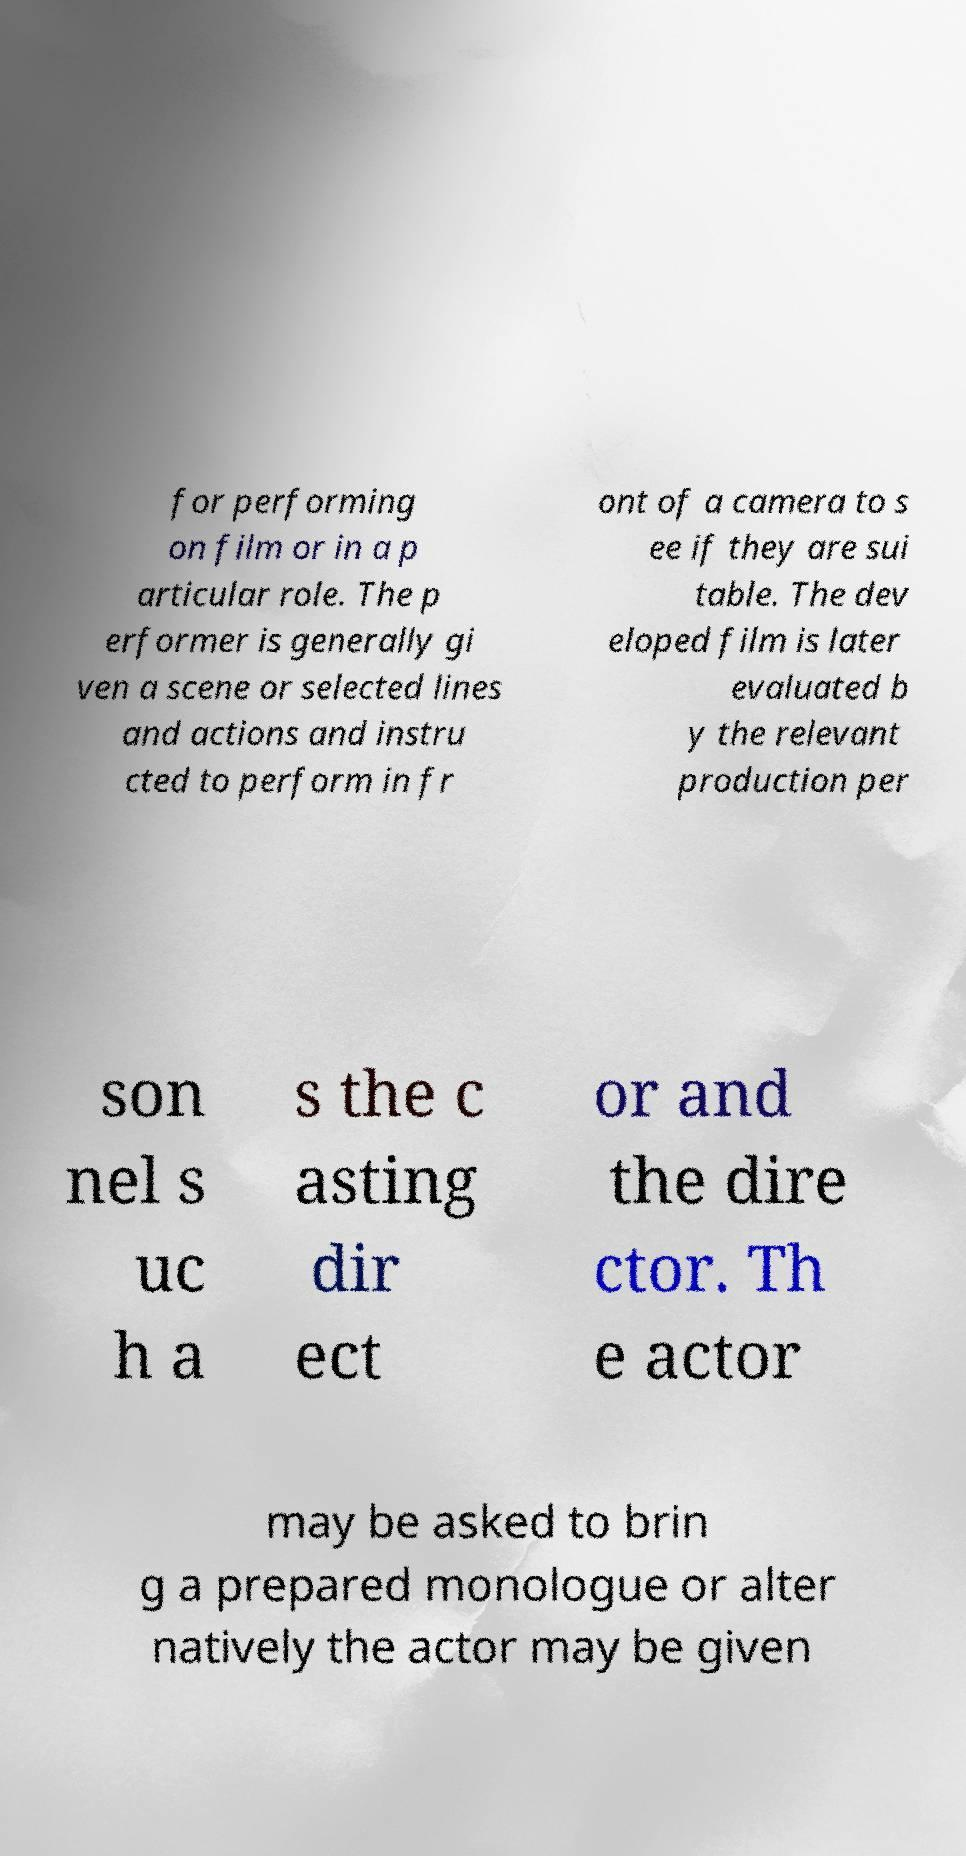Can you read and provide the text displayed in the image?This photo seems to have some interesting text. Can you extract and type it out for me? for performing on film or in a p articular role. The p erformer is generally gi ven a scene or selected lines and actions and instru cted to perform in fr ont of a camera to s ee if they are sui table. The dev eloped film is later evaluated b y the relevant production per son nel s uc h a s the c asting dir ect or and the dire ctor. Th e actor may be asked to brin g a prepared monologue or alter natively the actor may be given 